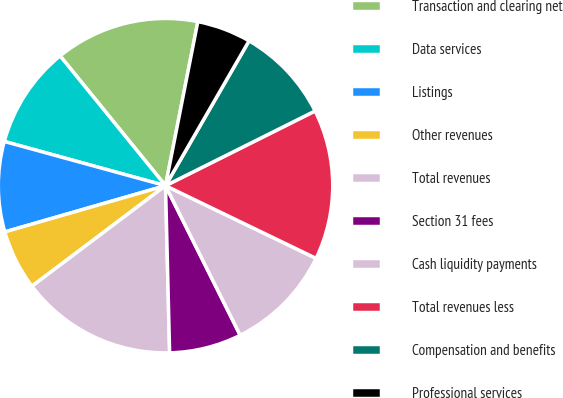Convert chart to OTSL. <chart><loc_0><loc_0><loc_500><loc_500><pie_chart><fcel>Transaction and clearing net<fcel>Data services<fcel>Listings<fcel>Other revenues<fcel>Total revenues<fcel>Section 31 fees<fcel>Cash liquidity payments<fcel>Total revenues less<fcel>Compensation and benefits<fcel>Professional services<nl><fcel>13.95%<fcel>9.88%<fcel>8.72%<fcel>5.81%<fcel>15.12%<fcel>6.98%<fcel>10.47%<fcel>14.53%<fcel>9.3%<fcel>5.23%<nl></chart> 